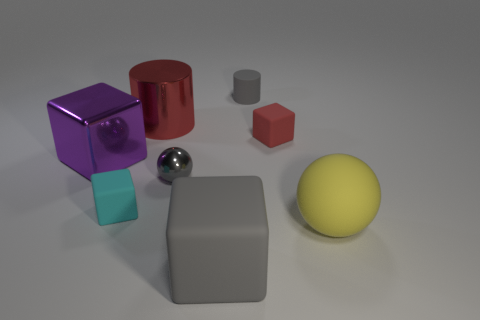Subtract all matte cubes. How many cubes are left? 1 Subtract all gray blocks. How many blocks are left? 3 Add 1 large metallic cylinders. How many objects exist? 9 Subtract all yellow blocks. Subtract all red spheres. How many blocks are left? 4 Subtract all cylinders. How many objects are left? 6 Add 8 large yellow matte cylinders. How many large yellow matte cylinders exist? 8 Subtract 0 yellow blocks. How many objects are left? 8 Subtract all rubber objects. Subtract all big red objects. How many objects are left? 2 Add 4 small gray balls. How many small gray balls are left? 5 